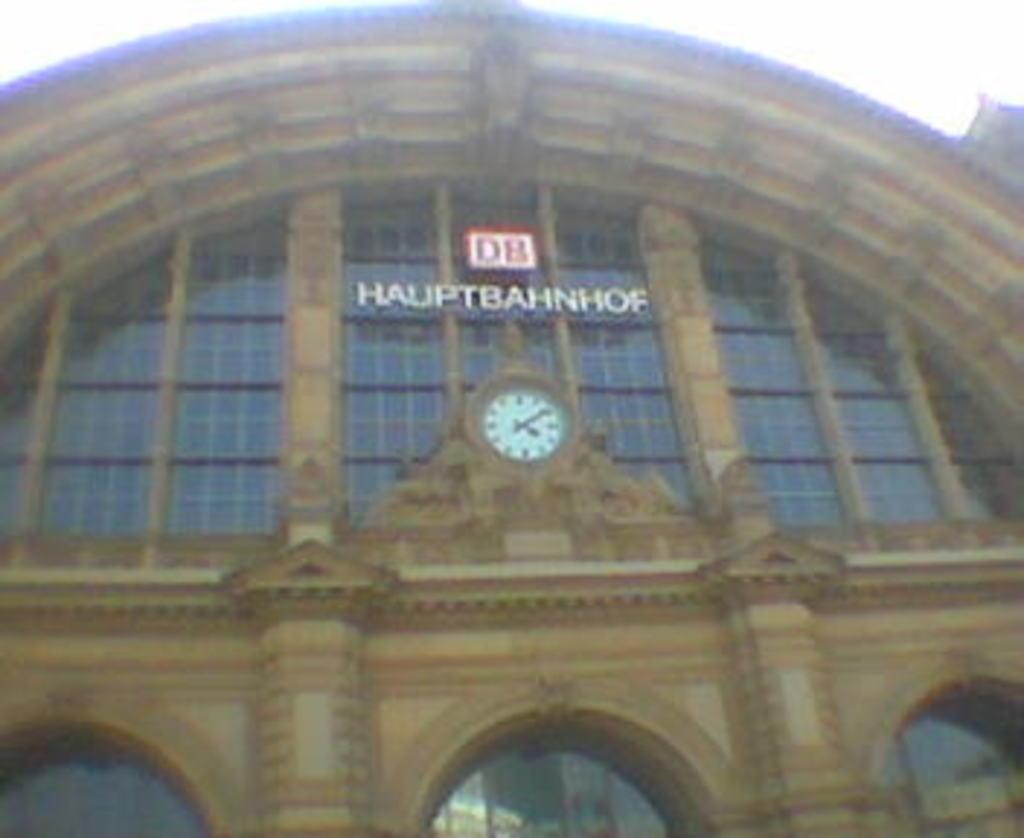What structure is present in the image? There is a building in the image. Is there any specific feature attached to the building? Yes, there is a clock attached to the building. Can you see a girl holding a stick and a list in the image? There is no girl, stick, or list present in the image; it only features a building with a clock attached to it. 